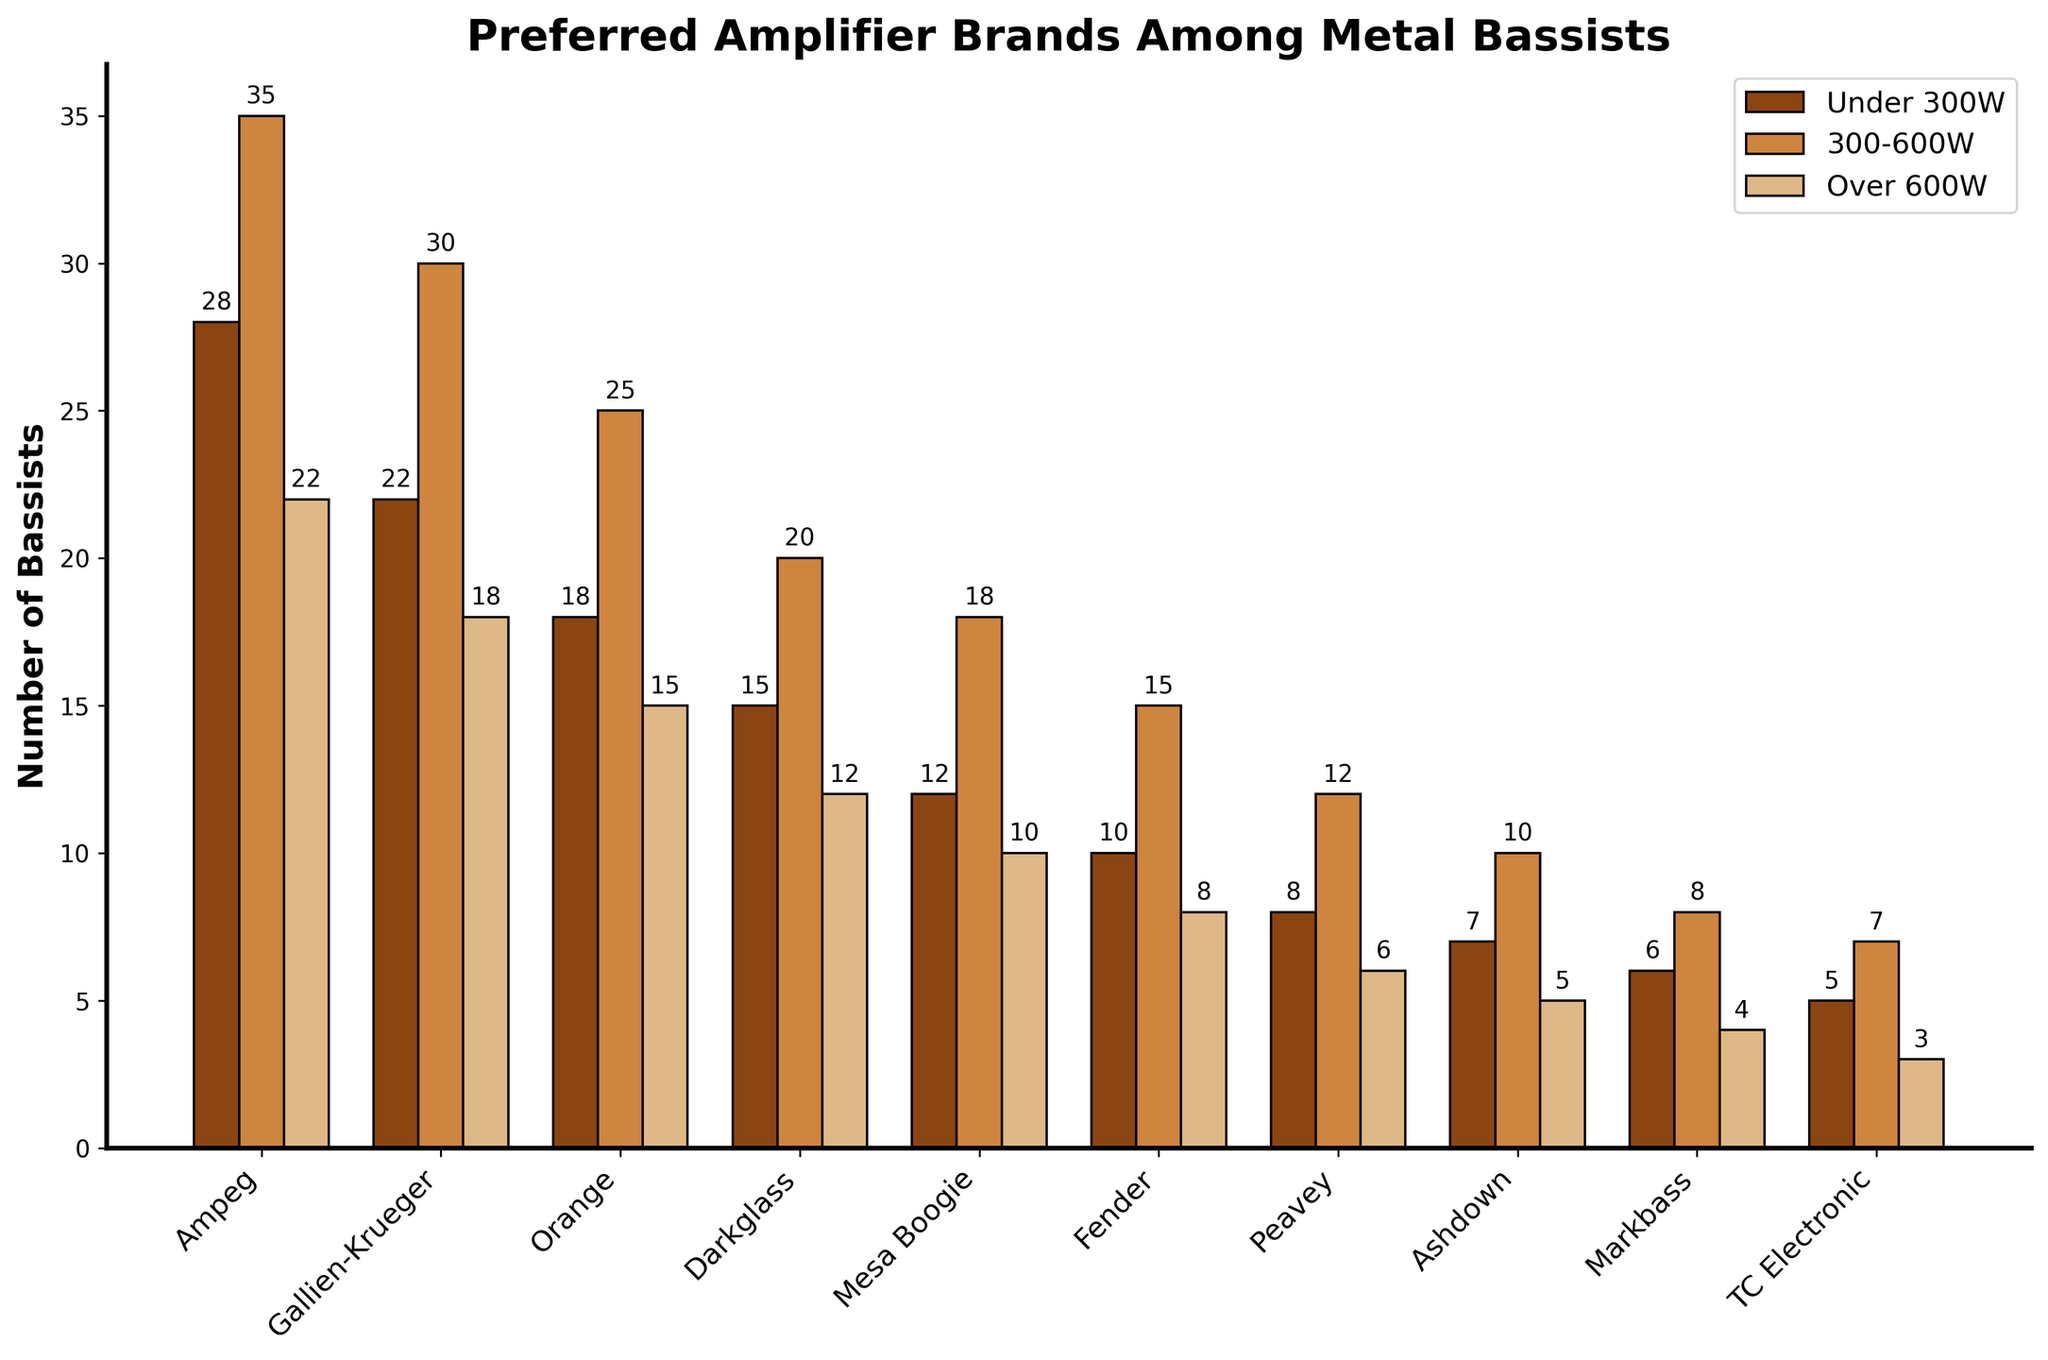How many brands have more bassists using amplifiers under 300W than over 600W? Count the brands for which the "Under 300W" bar height is taller than the "Over 600W" bar height. These brands are Ampeg, Gallien-Krueger, Orange, Darkglass, Mesa Boogie, Fender, Peavey, Ashdown, Markbass, and TC Electronic. Thus, all 10 brands meet this condition.
Answer: 10 Which brand has the highest number of bassists using amplifiers in the 300-600W range? Look for the brand with the tallest bar in the "300-600W" segment. Ampeg has the tallest bar with 35 bassists.
Answer: Ampeg Are there any brands where the number of bassists using amplifiers over 600W is higher than those using amplifiers under 300W? Compare the heights of the bars for "Under 300W" and "Over 600W" for each brand. No brand has a taller bar for "Over 600W" than for "Under 300W".
Answer: No What is the total number of bassists using Fender amplifiers across all wattage segments? Sum the numbers for Fender in each segment: 10 (Under 300W) + 15 (300-600W) + 8 (Over 600W) = 33.
Answer: 33 How does the number of bassists using Gallien-Krueger under 300W compare to those using Ampeg over 600W? Compare the heights of the bars for Gallien-Krueger under 300W (22) and Ampeg over 600W (22). They are equal.
Answer: Equal Which amplifier brand has the lowest preference among bassists for amplifiers over 600W? Identify the brand with the shortest bar in the "Over 600W" segment. TC Electronic has the shortest bar with 3 bassists.
Answer: TC Electronic How many more bassists prefer Ampeg amplifiers in the 300-600W range than in the under 300W range? Subtract the number of bassists using Ampeg under 300W (28) from those using Ampeg in the 300-600W range (35). The difference is 35 - 28 = 7.
Answer: 7 What is the average number of bassists using amplifiers under 300W for the top three brands (Ampeg, Gallien-Krueger, Orange)? Sum the numbers for these brands under 300W and divide by 3. (28 + 22 + 18) / 3 = 68 / 3 ≈ 22.67.
Answer: 22.67 